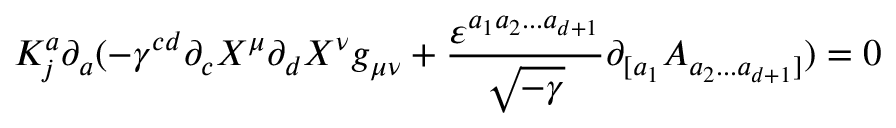Convert formula to latex. <formula><loc_0><loc_0><loc_500><loc_500>K _ { j } ^ { a } \partial _ { a } ( - \gamma ^ { c d } \partial _ { c } X ^ { \mu } \partial _ { d } X ^ { \nu } g _ { \mu \nu } + \frac { \varepsilon ^ { a _ { 1 } a _ { 2 } \dots a _ { d + 1 } } } { \sqrt { - \gamma } } \partial _ { [ a _ { 1 } } A _ { a _ { 2 } \dots a _ { d + 1 } ] } ) = 0</formula> 